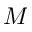Convert formula to latex. <formula><loc_0><loc_0><loc_500><loc_500>M</formula> 